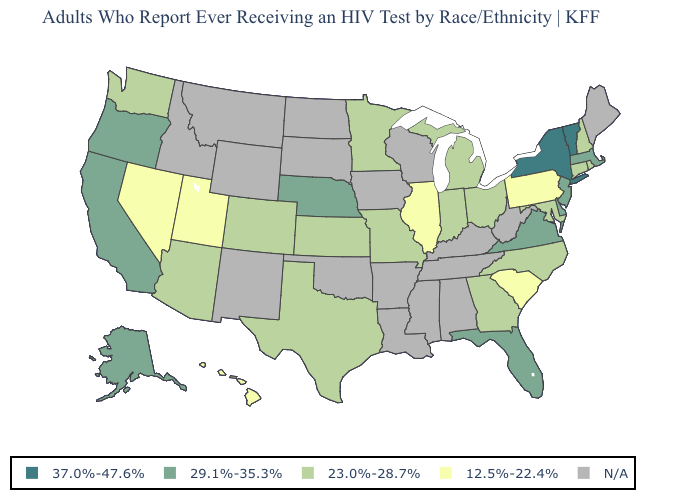Name the states that have a value in the range N/A?
Be succinct. Alabama, Arkansas, Idaho, Iowa, Kentucky, Louisiana, Maine, Mississippi, Montana, New Mexico, North Dakota, Oklahoma, South Dakota, Tennessee, West Virginia, Wisconsin, Wyoming. Among the states that border Washington , which have the highest value?
Concise answer only. Oregon. What is the highest value in the MidWest ?
Answer briefly. 29.1%-35.3%. Which states have the highest value in the USA?
Give a very brief answer. New York, Vermont. Which states have the lowest value in the USA?
Give a very brief answer. Hawaii, Illinois, Nevada, Pennsylvania, South Carolina, Utah. Name the states that have a value in the range N/A?
Give a very brief answer. Alabama, Arkansas, Idaho, Iowa, Kentucky, Louisiana, Maine, Mississippi, Montana, New Mexico, North Dakota, Oklahoma, South Dakota, Tennessee, West Virginia, Wisconsin, Wyoming. Name the states that have a value in the range 23.0%-28.7%?
Concise answer only. Arizona, Colorado, Connecticut, Georgia, Indiana, Kansas, Maryland, Michigan, Minnesota, Missouri, New Hampshire, North Carolina, Ohio, Rhode Island, Texas, Washington. Among the states that border Vermont , does Massachusetts have the highest value?
Be succinct. No. What is the value of Oklahoma?
Short answer required. N/A. What is the value of Maryland?
Keep it brief. 23.0%-28.7%. Name the states that have a value in the range 12.5%-22.4%?
Write a very short answer. Hawaii, Illinois, Nevada, Pennsylvania, South Carolina, Utah. Among the states that border California , does Nevada have the highest value?
Write a very short answer. No. Among the states that border Georgia , does Florida have the highest value?
Keep it brief. Yes. Among the states that border Rhode Island , does Connecticut have the lowest value?
Give a very brief answer. Yes. 